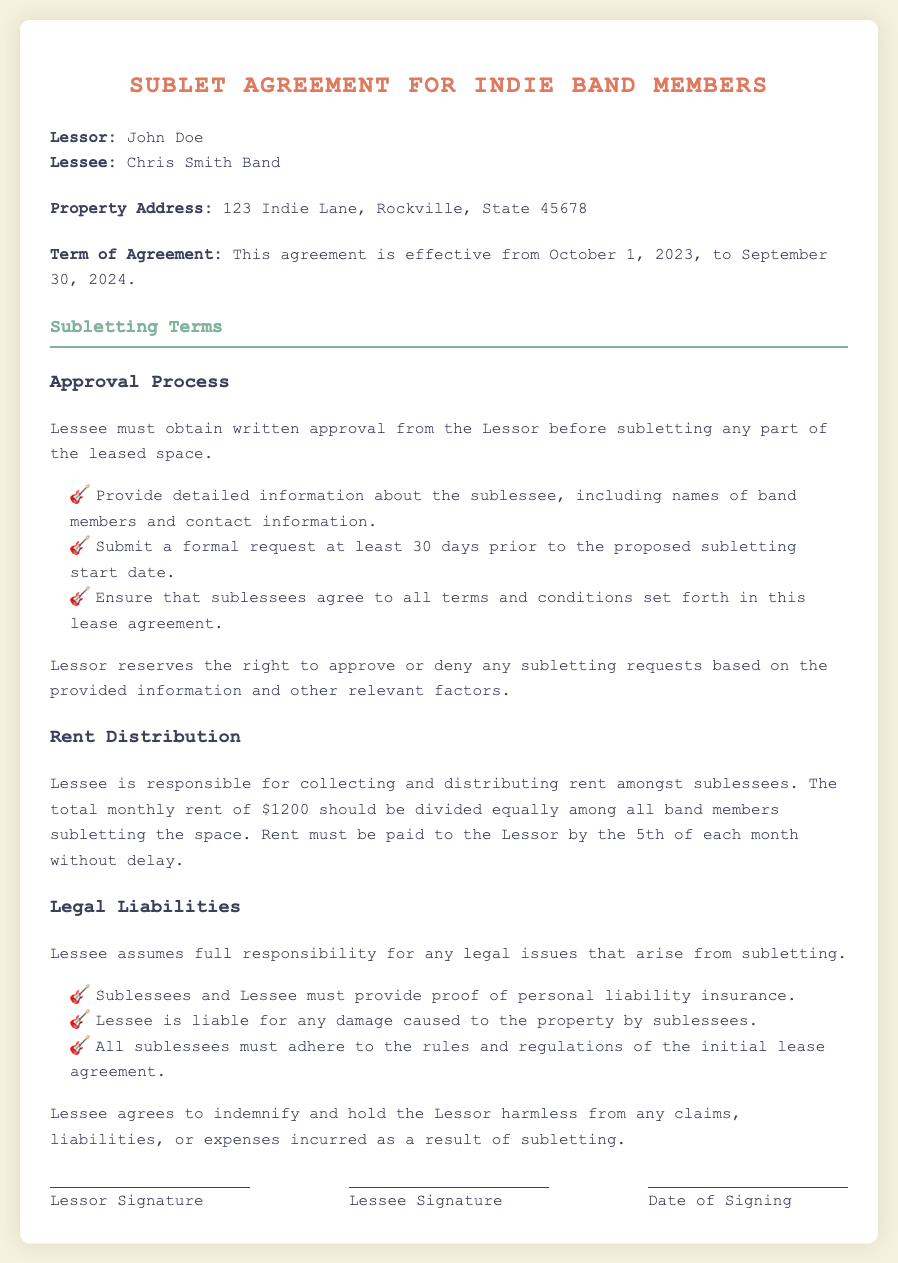What is the name of the Lessor? The name of the Lessor is provided in the document under the parties section.
Answer: John Doe What is the property address? The property address is specified in the property section.
Answer: 123 Indie Lane, Rockville, State 45678 What is the total monthly rent? The total monthly rent is mentioned in the rent distribution section.
Answer: $1200 What is the term of the agreement? The term of the agreement is outlined in the term section under the effective dates.
Answer: October 1, 2023, to September 30, 2024 How many days in advance must the Lessee submit a request for subletting? The required notice period is detailed in the approval process section.
Answer: 30 days What liability insurance proof is required? The legal liabilities section states that both sublessees and Lessee must provide certain documentation.
Answer: Personal liability insurance Who is responsible for collecting rent amongst sublessees? The responsibility for rent collection is described in the rent distribution section of the document.
Answer: Lessee Can the Lessor deny subletting requests? The document indicates the Lessor's rights concerning subletting requests.
Answer: Yes What must sublessees agree to? Sublessees need to adhere to specific conditions as outlined in the approval process section.
Answer: All terms and conditions set forth in this lease agreement 